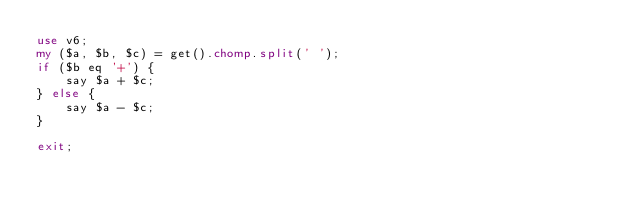Convert code to text. <code><loc_0><loc_0><loc_500><loc_500><_Perl_>use v6;
my ($a, $b, $c) = get().chomp.split(' ');
if ($b eq '+') {
	say $a + $c;
} else {
	say $a - $c;
}

exit;</code> 